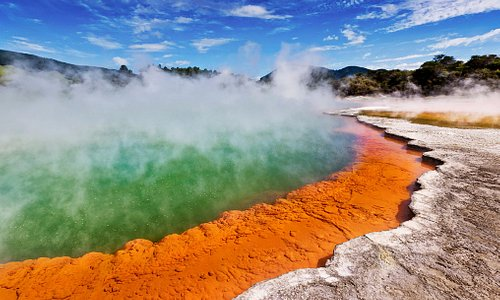What impact does this thermal activity have on the local environment? The thermal activity at locations like Wai-O-Tapu has a profound effect on the local environment. It creates unique ecosystems that can support a variety of extremophile microorganisms, which thrive in high-temperature conditions. This, in turn, can affect plant life in the surrounding areas, often leading to the development of specialized plant species. Additionally, the heat from the geothermal activity often results in localized weather patterns, such as increased humidity and mist, which can influence the overall climate of the region. 